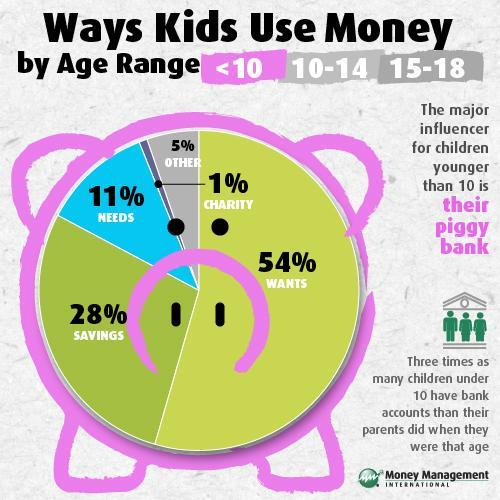What is the total percentage of money used for Wants and needs for kids?
Answer the question with a short phrase. 65% What is the total percentage of money used for charity and other usage for kids? 6% 